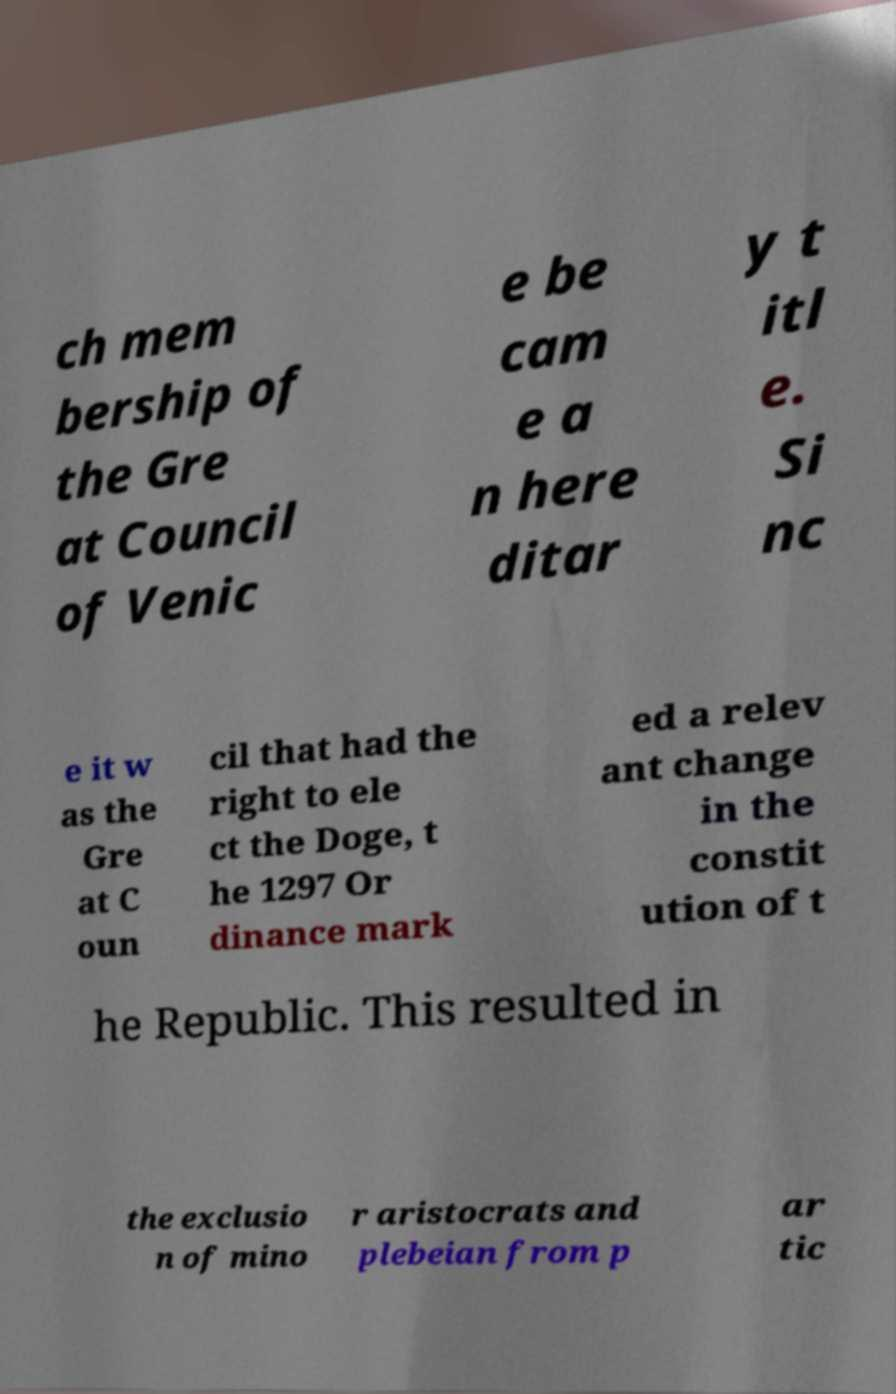There's text embedded in this image that I need extracted. Can you transcribe it verbatim? ch mem bership of the Gre at Council of Venic e be cam e a n here ditar y t itl e. Si nc e it w as the Gre at C oun cil that had the right to ele ct the Doge, t he 1297 Or dinance mark ed a relev ant change in the constit ution of t he Republic. This resulted in the exclusio n of mino r aristocrats and plebeian from p ar tic 